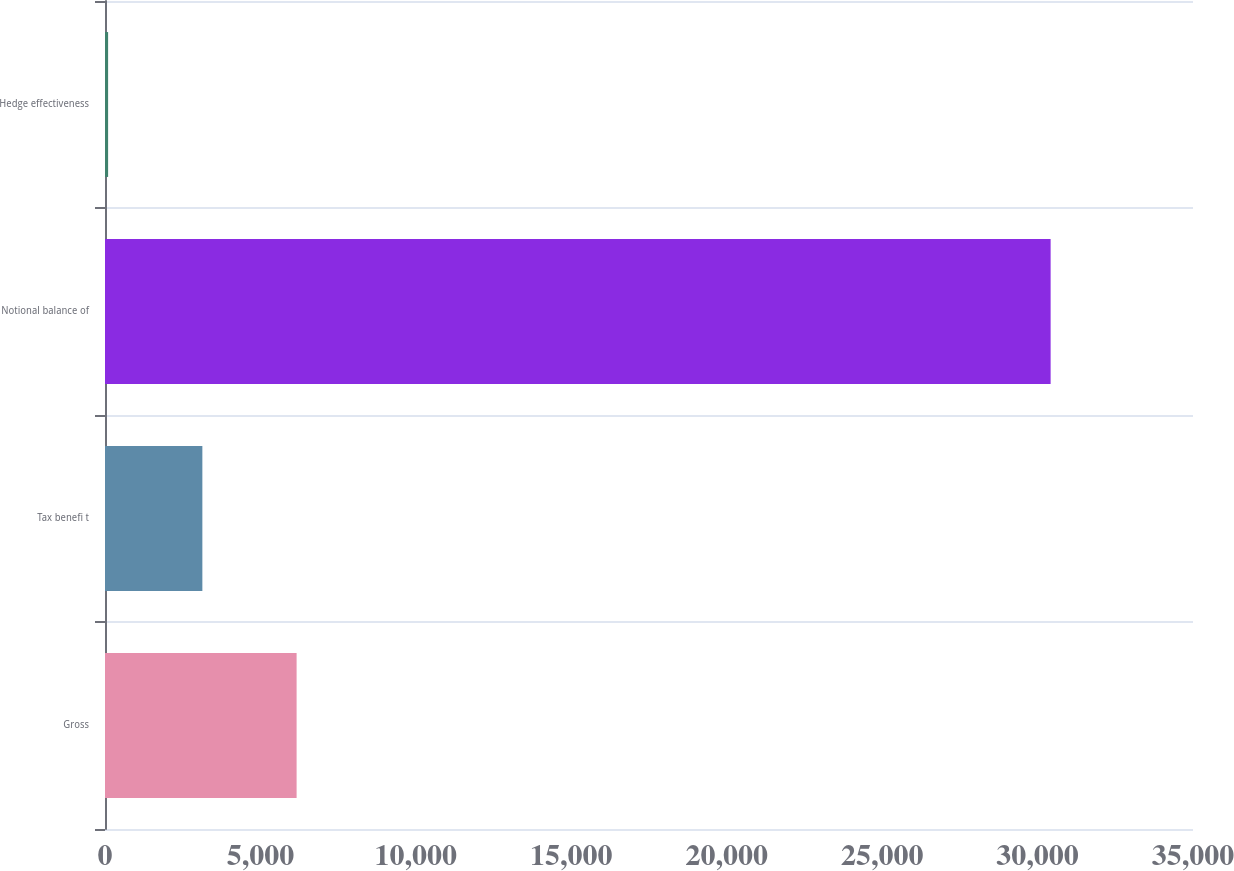Convert chart. <chart><loc_0><loc_0><loc_500><loc_500><bar_chart><fcel>Gross<fcel>Tax benefi t<fcel>Notional balance of<fcel>Hedge effectiveness<nl><fcel>6164<fcel>3132<fcel>30420<fcel>100<nl></chart> 